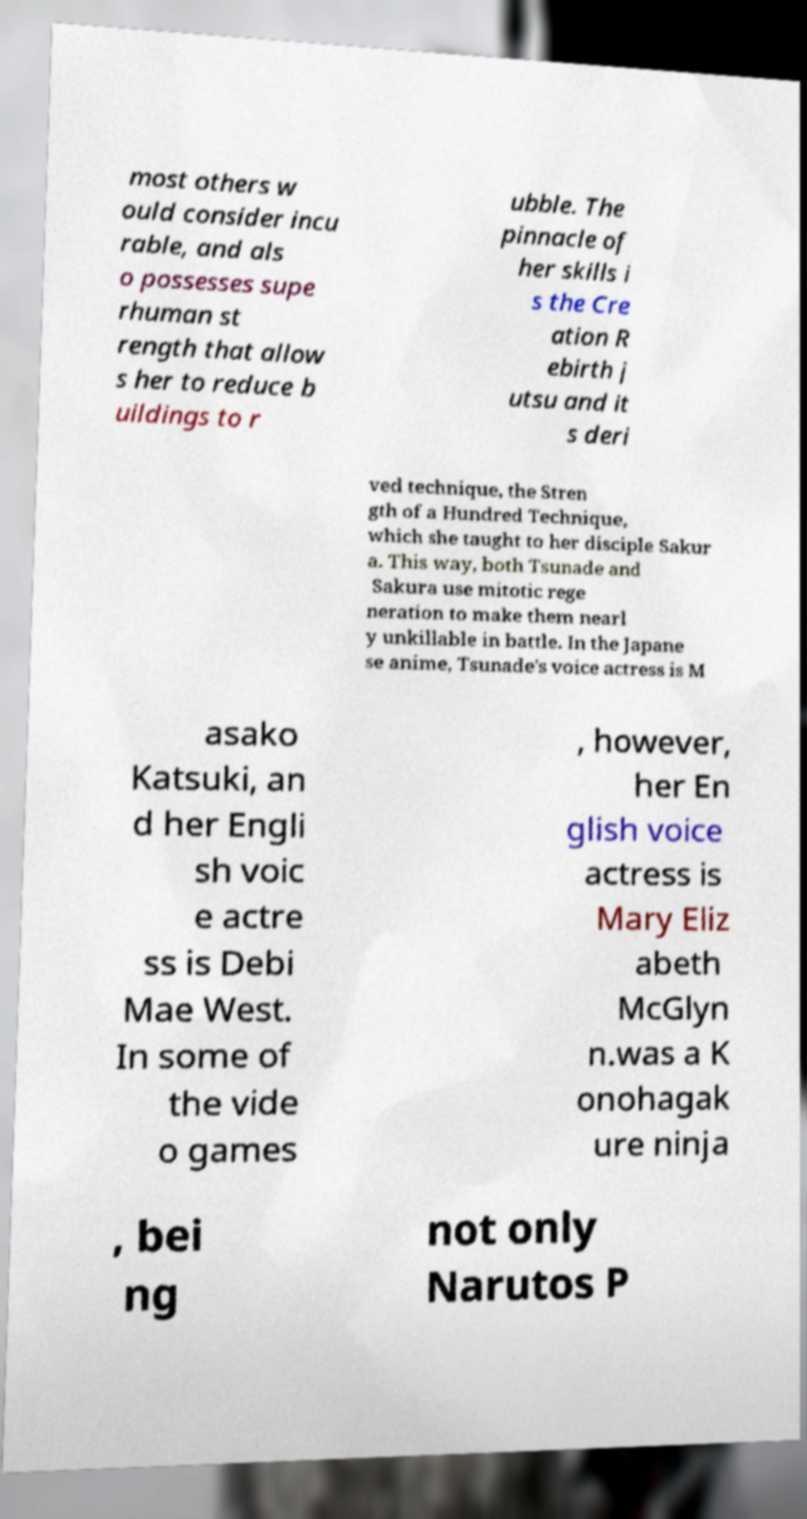Please identify and transcribe the text found in this image. most others w ould consider incu rable, and als o possesses supe rhuman st rength that allow s her to reduce b uildings to r ubble. The pinnacle of her skills i s the Cre ation R ebirth j utsu and it s deri ved technique, the Stren gth of a Hundred Technique, which she taught to her disciple Sakur a. This way, both Tsunade and Sakura use mitotic rege neration to make them nearl y unkillable in battle. In the Japane se anime, Tsunade's voice actress is M asako Katsuki, an d her Engli sh voic e actre ss is Debi Mae West. In some of the vide o games , however, her En glish voice actress is Mary Eliz abeth McGlyn n.was a K onohagak ure ninja , bei ng not only Narutos P 